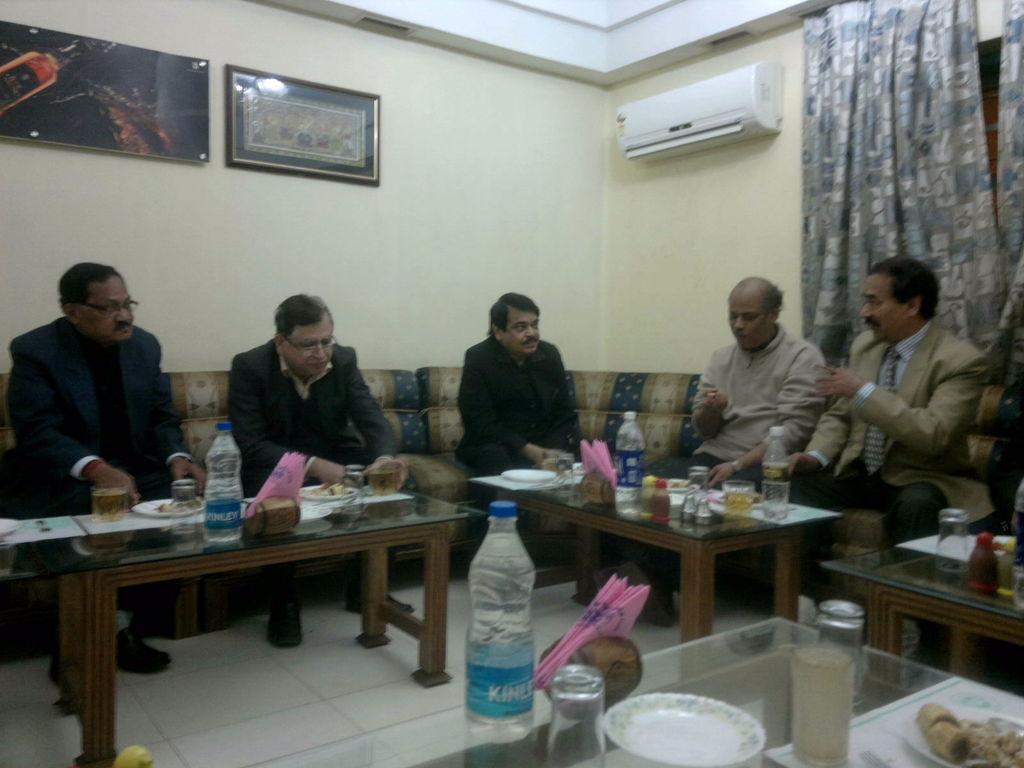Can you describe this image briefly? There are five persons sitting on a sofa. In front of them there are four table. On the table there are bottles, tissues , plates, glass, food items. In the background there is a wall. There are two photo frames, an AC and curtain. 